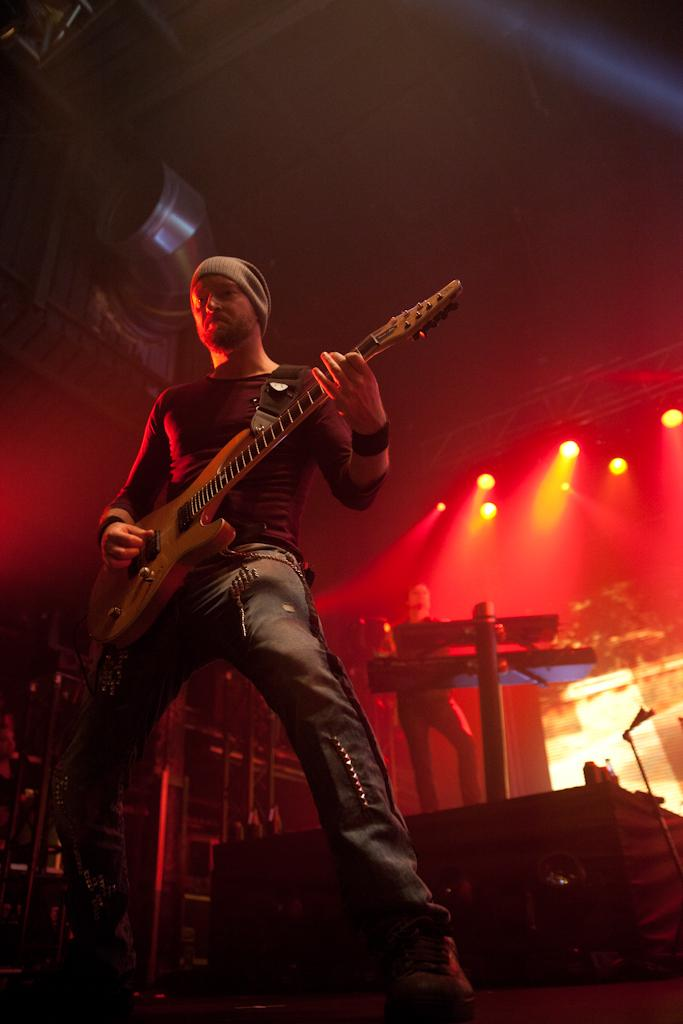How many people are in the image? There are two people in the image. What is one of the people holding? One person is holding a guitar. Can you describe the clothing of the person holding the guitar? The person holding the guitar is wearing a cap. What can be seen in the background of the image? There are lights visible in the background of the image. What type of toys can be seen on the plate in the image? There is no plate or toys present in the image. Can you describe the sound of the fly buzzing around the person holding the guitar? There is no fly present in the image, so it is not possible to describe its sound. 